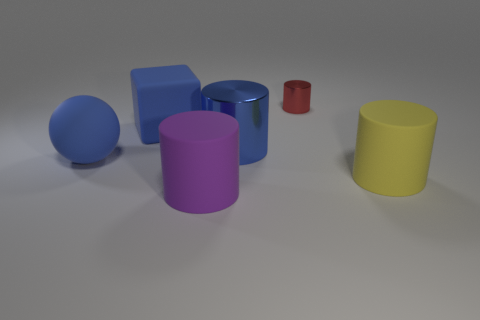Add 1 small red metallic objects. How many objects exist? 7 Subtract all spheres. How many objects are left? 5 Add 2 big red rubber cubes. How many big red rubber cubes exist? 2 Subtract 0 cyan cubes. How many objects are left? 6 Subtract all small rubber things. Subtract all purple rubber things. How many objects are left? 5 Add 4 yellow cylinders. How many yellow cylinders are left? 5 